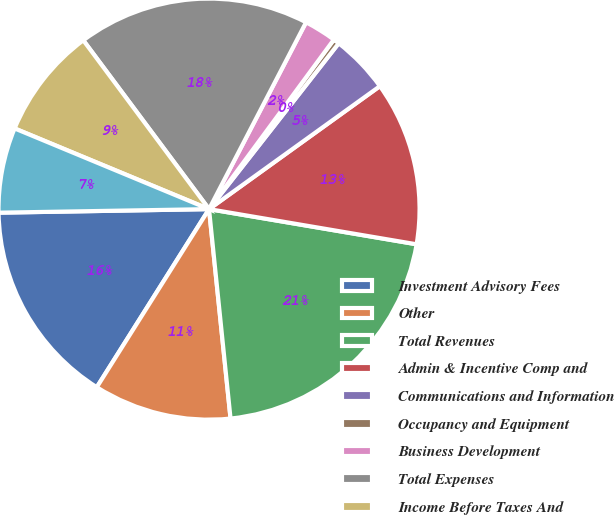<chart> <loc_0><loc_0><loc_500><loc_500><pie_chart><fcel>Investment Advisory Fees<fcel>Other<fcel>Total Revenues<fcel>Admin & Incentive Comp and<fcel>Communications and Information<fcel>Occupancy and Equipment<fcel>Business Development<fcel>Total Expenses<fcel>Income Before Taxes And<fcel>Pre-tax Income<nl><fcel>15.78%<fcel>10.58%<fcel>20.7%<fcel>12.6%<fcel>4.51%<fcel>0.46%<fcel>2.48%<fcel>17.81%<fcel>8.55%<fcel>6.53%<nl></chart> 